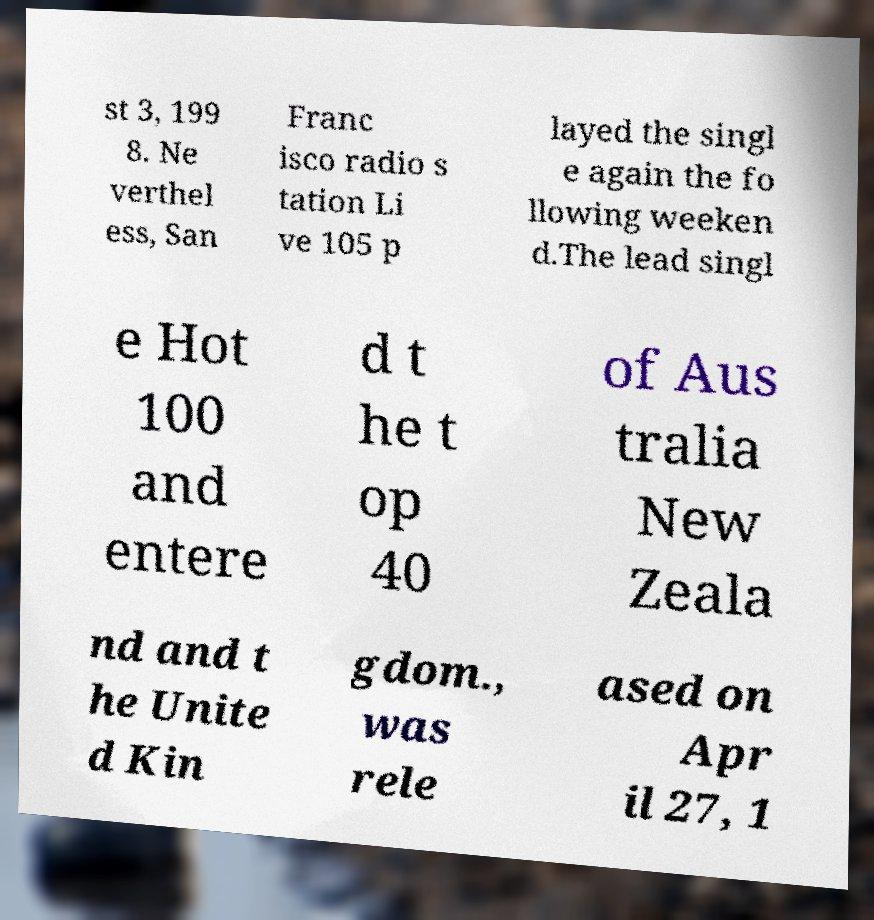Can you accurately transcribe the text from the provided image for me? st 3, 199 8. Ne verthel ess, San Franc isco radio s tation Li ve 105 p layed the singl e again the fo llowing weeken d.The lead singl e Hot 100 and entere d t he t op 40 of Aus tralia New Zeala nd and t he Unite d Kin gdom., was rele ased on Apr il 27, 1 